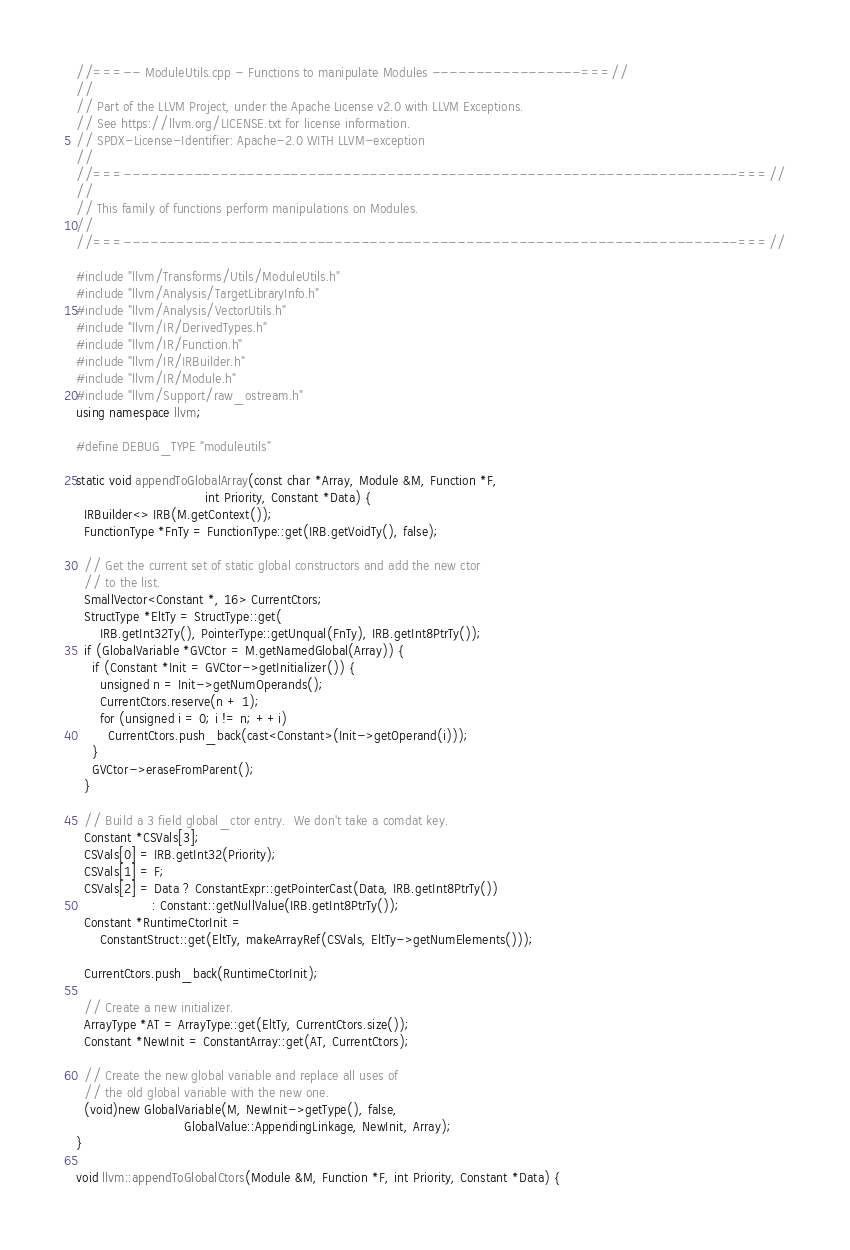Convert code to text. <code><loc_0><loc_0><loc_500><loc_500><_C++_>//===-- ModuleUtils.cpp - Functions to manipulate Modules -----------------===//
//
// Part of the LLVM Project, under the Apache License v2.0 with LLVM Exceptions.
// See https://llvm.org/LICENSE.txt for license information.
// SPDX-License-Identifier: Apache-2.0 WITH LLVM-exception
//
//===----------------------------------------------------------------------===//
//
// This family of functions perform manipulations on Modules.
//
//===----------------------------------------------------------------------===//

#include "llvm/Transforms/Utils/ModuleUtils.h"
#include "llvm/Analysis/TargetLibraryInfo.h"
#include "llvm/Analysis/VectorUtils.h"
#include "llvm/IR/DerivedTypes.h"
#include "llvm/IR/Function.h"
#include "llvm/IR/IRBuilder.h"
#include "llvm/IR/Module.h"
#include "llvm/Support/raw_ostream.h"
using namespace llvm;

#define DEBUG_TYPE "moduleutils"

static void appendToGlobalArray(const char *Array, Module &M, Function *F,
                                int Priority, Constant *Data) {
  IRBuilder<> IRB(M.getContext());
  FunctionType *FnTy = FunctionType::get(IRB.getVoidTy(), false);

  // Get the current set of static global constructors and add the new ctor
  // to the list.
  SmallVector<Constant *, 16> CurrentCtors;
  StructType *EltTy = StructType::get(
      IRB.getInt32Ty(), PointerType::getUnqual(FnTy), IRB.getInt8PtrTy());
  if (GlobalVariable *GVCtor = M.getNamedGlobal(Array)) {
    if (Constant *Init = GVCtor->getInitializer()) {
      unsigned n = Init->getNumOperands();
      CurrentCtors.reserve(n + 1);
      for (unsigned i = 0; i != n; ++i)
        CurrentCtors.push_back(cast<Constant>(Init->getOperand(i)));
    }
    GVCtor->eraseFromParent();
  }

  // Build a 3 field global_ctor entry.  We don't take a comdat key.
  Constant *CSVals[3];
  CSVals[0] = IRB.getInt32(Priority);
  CSVals[1] = F;
  CSVals[2] = Data ? ConstantExpr::getPointerCast(Data, IRB.getInt8PtrTy())
                   : Constant::getNullValue(IRB.getInt8PtrTy());
  Constant *RuntimeCtorInit =
      ConstantStruct::get(EltTy, makeArrayRef(CSVals, EltTy->getNumElements()));

  CurrentCtors.push_back(RuntimeCtorInit);

  // Create a new initializer.
  ArrayType *AT = ArrayType::get(EltTy, CurrentCtors.size());
  Constant *NewInit = ConstantArray::get(AT, CurrentCtors);

  // Create the new global variable and replace all uses of
  // the old global variable with the new one.
  (void)new GlobalVariable(M, NewInit->getType(), false,
                           GlobalValue::AppendingLinkage, NewInit, Array);
}

void llvm::appendToGlobalCtors(Module &M, Function *F, int Priority, Constant *Data) {</code> 